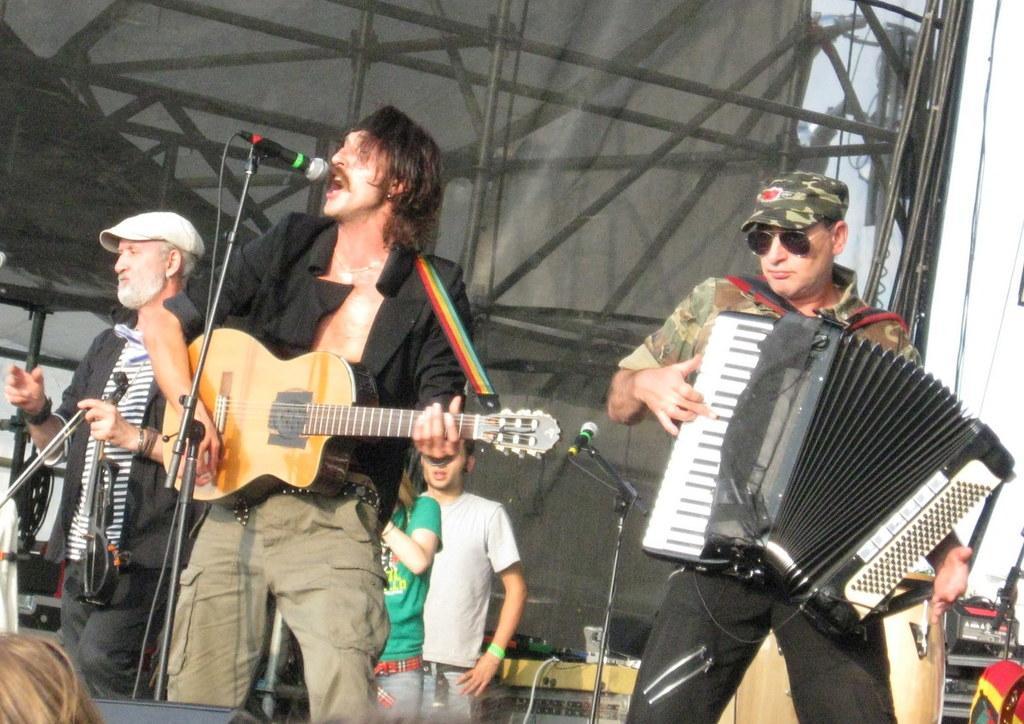Could you give a brief overview of what you see in this image? Here we can see a group of people, the guy in the right side is playing in musical instrument the guy in the center is playing the guitar and singing a song with a microphone in front of him 